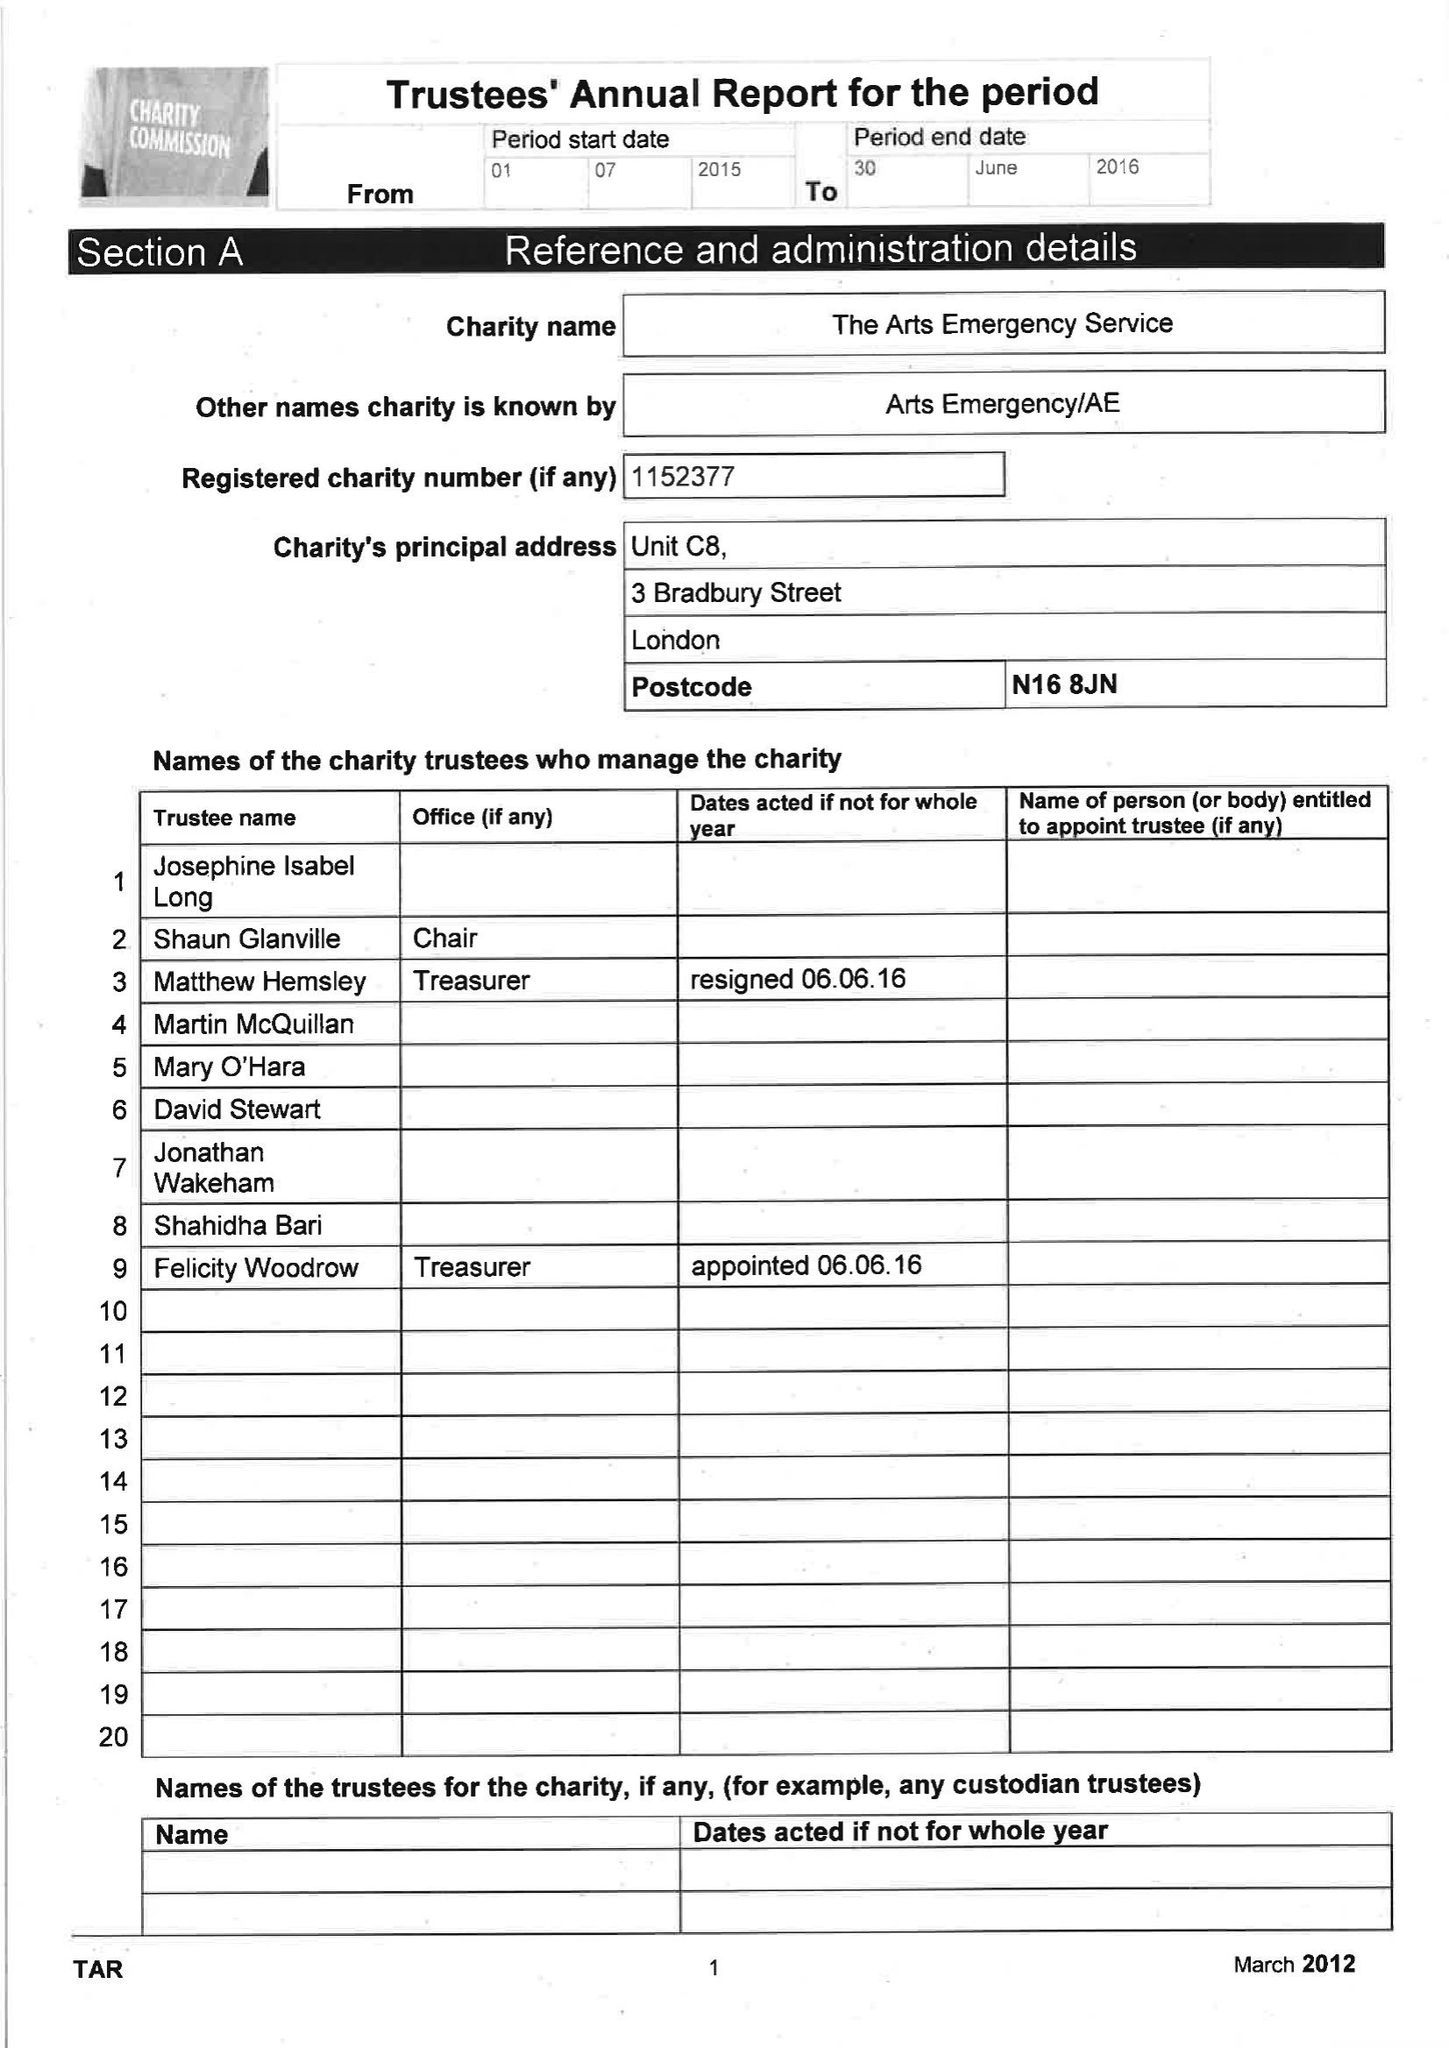What is the value for the address__post_town?
Answer the question using a single word or phrase. LONDON 